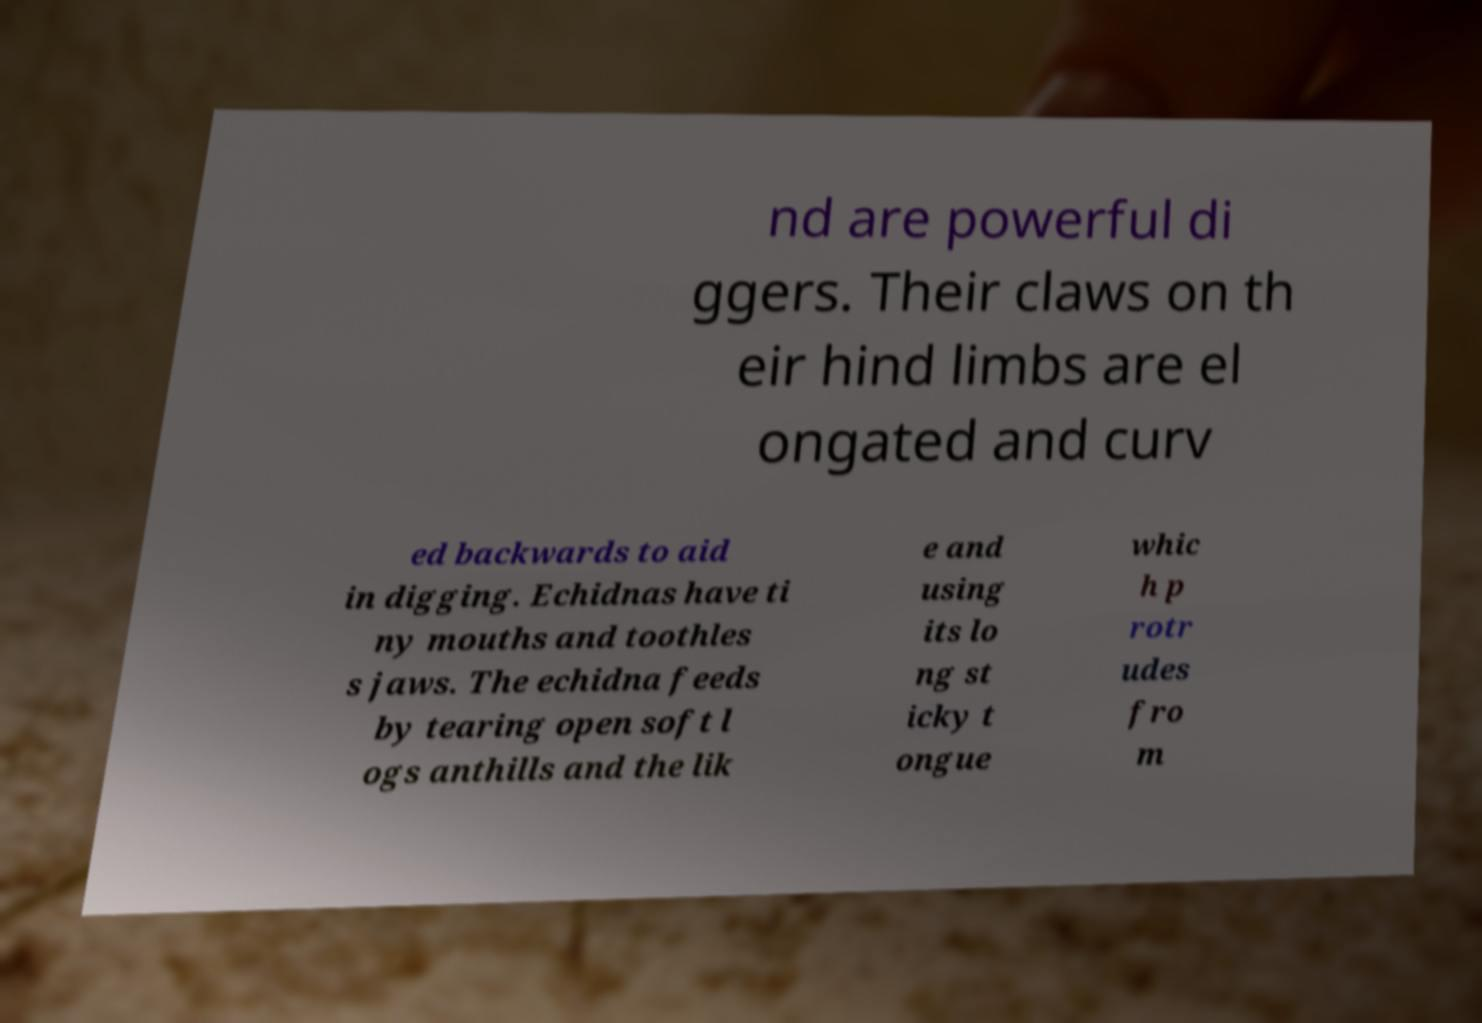For documentation purposes, I need the text within this image transcribed. Could you provide that? nd are powerful di ggers. Their claws on th eir hind limbs are el ongated and curv ed backwards to aid in digging. Echidnas have ti ny mouths and toothles s jaws. The echidna feeds by tearing open soft l ogs anthills and the lik e and using its lo ng st icky t ongue whic h p rotr udes fro m 